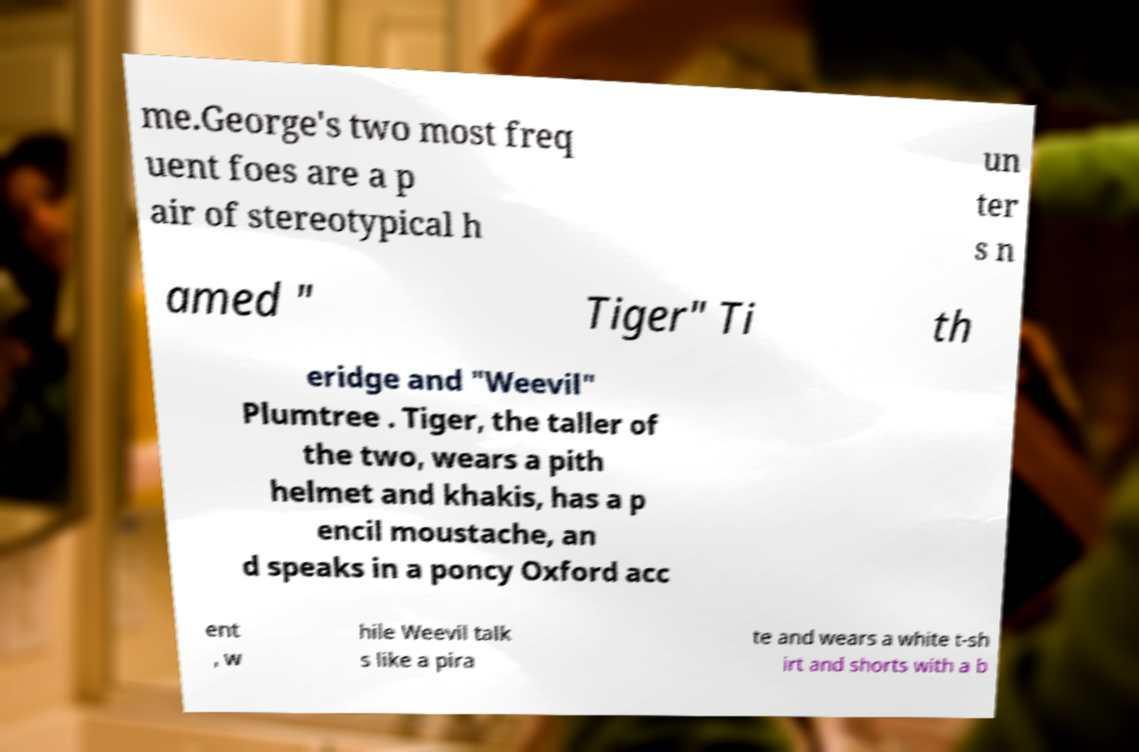Please identify and transcribe the text found in this image. me.George's two most freq uent foes are a p air of stereotypical h un ter s n amed " Tiger" Ti th eridge and "Weevil" Plumtree . Tiger, the taller of the two, wears a pith helmet and khakis, has a p encil moustache, an d speaks in a poncy Oxford acc ent , w hile Weevil talk s like a pira te and wears a white t-sh irt and shorts with a b 